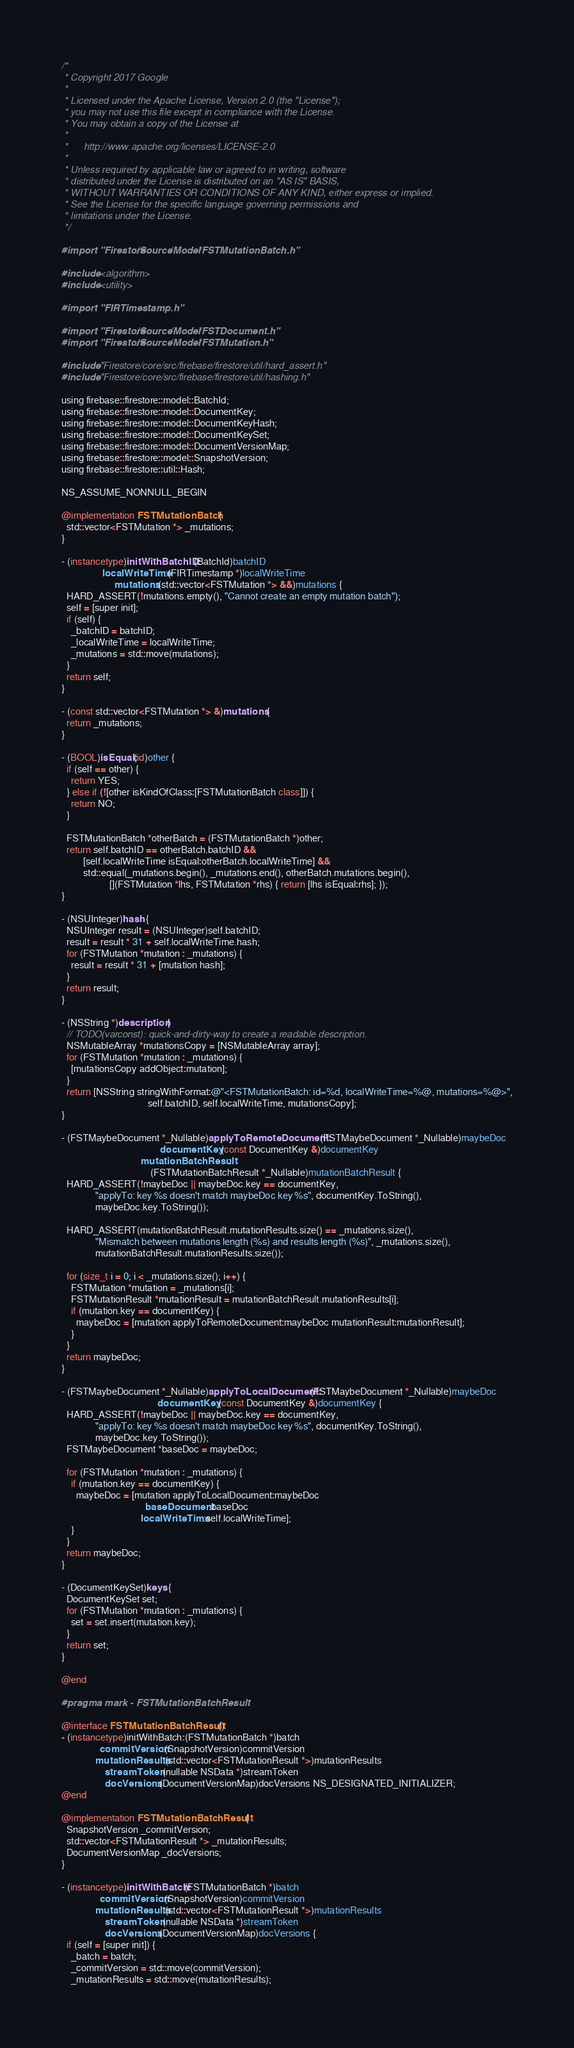<code> <loc_0><loc_0><loc_500><loc_500><_ObjectiveC_>/*
 * Copyright 2017 Google
 *
 * Licensed under the Apache License, Version 2.0 (the "License");
 * you may not use this file except in compliance with the License.
 * You may obtain a copy of the License at
 *
 *      http://www.apache.org/licenses/LICENSE-2.0
 *
 * Unless required by applicable law or agreed to in writing, software
 * distributed under the License is distributed on an "AS IS" BASIS,
 * WITHOUT WARRANTIES OR CONDITIONS OF ANY KIND, either express or implied.
 * See the License for the specific language governing permissions and
 * limitations under the License.
 */

#import "Firestore/Source/Model/FSTMutationBatch.h"

#include <algorithm>
#include <utility>

#import "FIRTimestamp.h"

#import "Firestore/Source/Model/FSTDocument.h"
#import "Firestore/Source/Model/FSTMutation.h"

#include "Firestore/core/src/firebase/firestore/util/hard_assert.h"
#include "Firestore/core/src/firebase/firestore/util/hashing.h"

using firebase::firestore::model::BatchId;
using firebase::firestore::model::DocumentKey;
using firebase::firestore::model::DocumentKeyHash;
using firebase::firestore::model::DocumentKeySet;
using firebase::firestore::model::DocumentVersionMap;
using firebase::firestore::model::SnapshotVersion;
using firebase::firestore::util::Hash;

NS_ASSUME_NONNULL_BEGIN

@implementation FSTMutationBatch {
  std::vector<FSTMutation *> _mutations;
}

- (instancetype)initWithBatchID:(BatchId)batchID
                 localWriteTime:(FIRTimestamp *)localWriteTime
                      mutations:(std::vector<FSTMutation *> &&)mutations {
  HARD_ASSERT(!mutations.empty(), "Cannot create an empty mutation batch");
  self = [super init];
  if (self) {
    _batchID = batchID;
    _localWriteTime = localWriteTime;
    _mutations = std::move(mutations);
  }
  return self;
}

- (const std::vector<FSTMutation *> &)mutations {
  return _mutations;
}

- (BOOL)isEqual:(id)other {
  if (self == other) {
    return YES;
  } else if (![other isKindOfClass:[FSTMutationBatch class]]) {
    return NO;
  }

  FSTMutationBatch *otherBatch = (FSTMutationBatch *)other;
  return self.batchID == otherBatch.batchID &&
         [self.localWriteTime isEqual:otherBatch.localWriteTime] &&
         std::equal(_mutations.begin(), _mutations.end(), otherBatch.mutations.begin(),
                    [](FSTMutation *lhs, FSTMutation *rhs) { return [lhs isEqual:rhs]; });
}

- (NSUInteger)hash {
  NSUInteger result = (NSUInteger)self.batchID;
  result = result * 31 + self.localWriteTime.hash;
  for (FSTMutation *mutation : _mutations) {
    result = result * 31 + [mutation hash];
  }
  return result;
}

- (NSString *)description {
  // TODO(varconst): quick-and-dirty-way to create a readable description.
  NSMutableArray *mutationsCopy = [NSMutableArray array];
  for (FSTMutation *mutation : _mutations) {
    [mutationsCopy addObject:mutation];
  }
  return [NSString stringWithFormat:@"<FSTMutationBatch: id=%d, localWriteTime=%@, mutations=%@>",
                                    self.batchID, self.localWriteTime, mutationsCopy];
}

- (FSTMaybeDocument *_Nullable)applyToRemoteDocument:(FSTMaybeDocument *_Nullable)maybeDoc
                                         documentKey:(const DocumentKey &)documentKey
                                 mutationBatchResult:
                                     (FSTMutationBatchResult *_Nullable)mutationBatchResult {
  HARD_ASSERT(!maybeDoc || maybeDoc.key == documentKey,
              "applyTo: key %s doesn't match maybeDoc key %s", documentKey.ToString(),
              maybeDoc.key.ToString());

  HARD_ASSERT(mutationBatchResult.mutationResults.size() == _mutations.size(),
              "Mismatch between mutations length (%s) and results length (%s)", _mutations.size(),
              mutationBatchResult.mutationResults.size());

  for (size_t i = 0; i < _mutations.size(); i++) {
    FSTMutation *mutation = _mutations[i];
    FSTMutationResult *mutationResult = mutationBatchResult.mutationResults[i];
    if (mutation.key == documentKey) {
      maybeDoc = [mutation applyToRemoteDocument:maybeDoc mutationResult:mutationResult];
    }
  }
  return maybeDoc;
}

- (FSTMaybeDocument *_Nullable)applyToLocalDocument:(FSTMaybeDocument *_Nullable)maybeDoc
                                        documentKey:(const DocumentKey &)documentKey {
  HARD_ASSERT(!maybeDoc || maybeDoc.key == documentKey,
              "applyTo: key %s doesn't match maybeDoc key %s", documentKey.ToString(),
              maybeDoc.key.ToString());
  FSTMaybeDocument *baseDoc = maybeDoc;

  for (FSTMutation *mutation : _mutations) {
    if (mutation.key == documentKey) {
      maybeDoc = [mutation applyToLocalDocument:maybeDoc
                                   baseDocument:baseDoc
                                 localWriteTime:self.localWriteTime];
    }
  }
  return maybeDoc;
}

- (DocumentKeySet)keys {
  DocumentKeySet set;
  for (FSTMutation *mutation : _mutations) {
    set = set.insert(mutation.key);
  }
  return set;
}

@end

#pragma mark - FSTMutationBatchResult

@interface FSTMutationBatchResult ()
- (instancetype)initWithBatch:(FSTMutationBatch *)batch
                commitVersion:(SnapshotVersion)commitVersion
              mutationResults:(std::vector<FSTMutationResult *>)mutationResults
                  streamToken:(nullable NSData *)streamToken
                  docVersions:(DocumentVersionMap)docVersions NS_DESIGNATED_INITIALIZER;
@end

@implementation FSTMutationBatchResult {
  SnapshotVersion _commitVersion;
  std::vector<FSTMutationResult *> _mutationResults;
  DocumentVersionMap _docVersions;
}

- (instancetype)initWithBatch:(FSTMutationBatch *)batch
                commitVersion:(SnapshotVersion)commitVersion
              mutationResults:(std::vector<FSTMutationResult *>)mutationResults
                  streamToken:(nullable NSData *)streamToken
                  docVersions:(DocumentVersionMap)docVersions {
  if (self = [super init]) {
    _batch = batch;
    _commitVersion = std::move(commitVersion);
    _mutationResults = std::move(mutationResults);</code> 